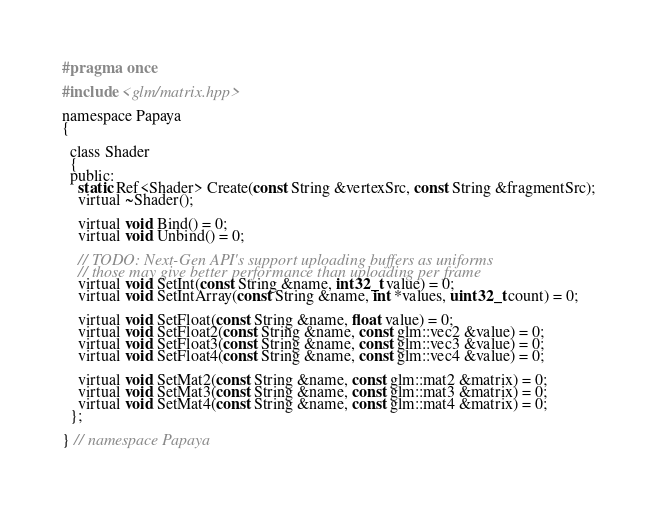Convert code to text. <code><loc_0><loc_0><loc_500><loc_500><_C_>#pragma once

#include <glm/matrix.hpp>

namespace Papaya
{

  class Shader
  {
  public:
    static Ref<Shader> Create(const String &vertexSrc, const String &fragmentSrc);
    virtual ~Shader();

    virtual void Bind() = 0;
    virtual void Unbind() = 0;

    // TODO: Next-Gen API's support uploading buffers as uniforms
    // those may give better performance than uploading per frame
    virtual void SetInt(const String &name, int32_t value) = 0;
    virtual void SetIntArray(const String &name, int *values, uint32_t count) = 0;

    virtual void SetFloat(const String &name, float value) = 0;
    virtual void SetFloat2(const String &name, const glm::vec2 &value) = 0;
    virtual void SetFloat3(const String &name, const glm::vec3 &value) = 0;
    virtual void SetFloat4(const String &name, const glm::vec4 &value) = 0;

    virtual void SetMat2(const String &name, const glm::mat2 &matrix) = 0;
    virtual void SetMat3(const String &name, const glm::mat3 &matrix) = 0;
    virtual void SetMat4(const String &name, const glm::mat4 &matrix) = 0;
  };

} // namespace Papaya</code> 